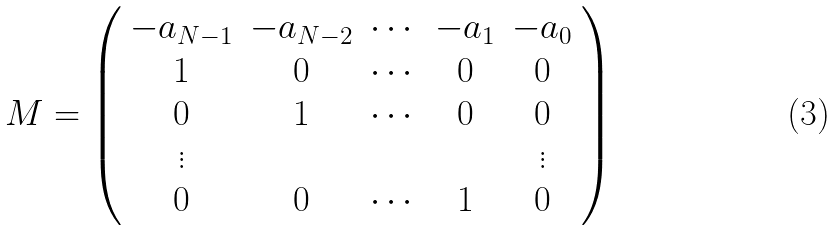<formula> <loc_0><loc_0><loc_500><loc_500>M = \left ( \begin{array} { c c c c c } - a _ { N - 1 } & - a _ { N - 2 } & \cdots & - a _ { 1 } & - a _ { 0 } \\ 1 & 0 & \cdots & 0 & 0 \\ 0 & 1 & \cdots & 0 & 0 \\ \vdots & & & & \vdots \\ 0 & 0 & \cdots & 1 & 0 \end{array} \right )</formula> 